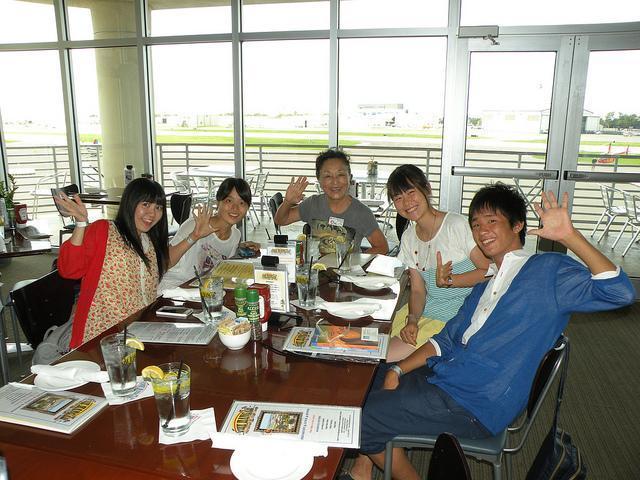How many people are sitting at the table?
Give a very brief answer. 5. How many books can be seen?
Give a very brief answer. 2. How many people are in the picture?
Give a very brief answer. 5. How many chairs are in the picture?
Give a very brief answer. 2. How many boats are in front of the church?
Give a very brief answer. 0. 